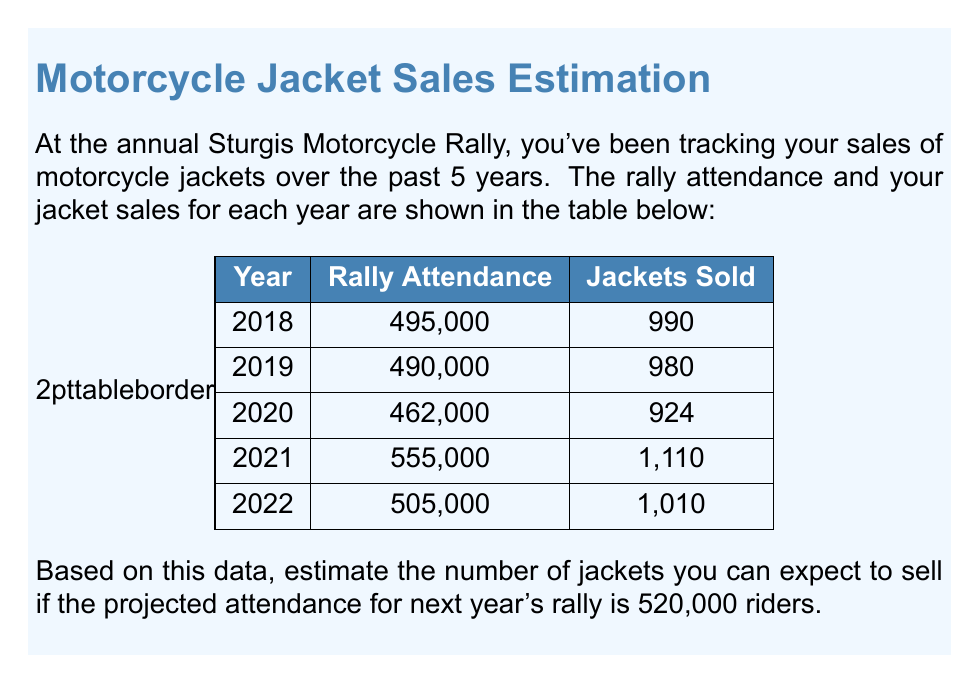Could you help me with this problem? To estimate the sales volume based on historical data, we'll use a simple linear regression model. This model assumes a linear relationship between rally attendance and jacket sales.

Step 1: Calculate the average attendance and average sales.
Average attendance = $(495000 + 490000 + 462000 + 555000 + 505000) / 5 = 501400$
Average sales = $(990 + 980 + 924 + 1110 + 1010) / 5 = 1002.8$

Step 2: Calculate the slope of the regression line.
The slope represents the change in sales for each unit change in attendance.

$$ \text{Slope} = \frac{\sum (x_i - \bar{x})(y_i - \bar{y})}{\sum (x_i - \bar{x})^2} $$

Where $x_i$ are attendance values, $y_i$ are sales values, and $\bar{x}$ and $\bar{y}$ are their respective means.

Calculating this:

$$ \text{Slope} = \frac{(495000 - 501400)(990 - 1002.8) + ... + (505000 - 501400)(1010 - 1002.8)}{(495000 - 501400)^2 + ... + (505000 - 501400)^2} $$

$$ \text{Slope} = 0.002 $$

Step 3: Calculate the y-intercept.
$$ y = mx + b $$
$$ 1002.8 = 0.002 * 501400 + b $$
$$ b = 1002.8 - 1002.8 = 0 $$

Step 4: Use the equation to estimate sales for 520,000 attendance.
$$ \text{Estimated Sales} = 0.002 * 520000 + 0 = 1040 $$

Therefore, we estimate selling 1,040 jackets if the rally attendance is 520,000.
Answer: 1,040 jackets 